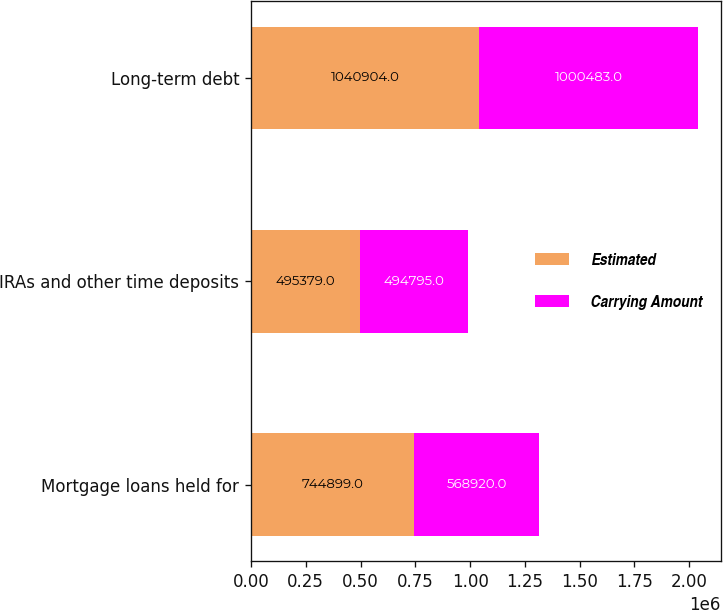<chart> <loc_0><loc_0><loc_500><loc_500><stacked_bar_chart><ecel><fcel>Mortgage loans held for<fcel>IRAs and other time deposits<fcel>Long-term debt<nl><fcel>Estimated<fcel>744899<fcel>495379<fcel>1.0409e+06<nl><fcel>Carrying Amount<fcel>568920<fcel>494795<fcel>1.00048e+06<nl></chart> 